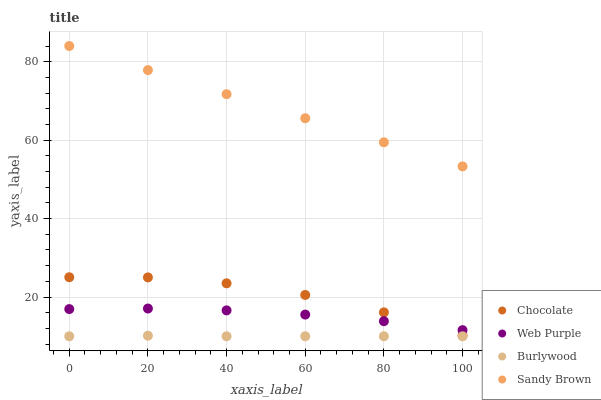Does Burlywood have the minimum area under the curve?
Answer yes or no. Yes. Does Sandy Brown have the maximum area under the curve?
Answer yes or no. Yes. Does Web Purple have the minimum area under the curve?
Answer yes or no. No. Does Web Purple have the maximum area under the curve?
Answer yes or no. No. Is Sandy Brown the smoothest?
Answer yes or no. Yes. Is Chocolate the roughest?
Answer yes or no. Yes. Is Web Purple the smoothest?
Answer yes or no. No. Is Web Purple the roughest?
Answer yes or no. No. Does Burlywood have the lowest value?
Answer yes or no. Yes. Does Web Purple have the lowest value?
Answer yes or no. No. Does Sandy Brown have the highest value?
Answer yes or no. Yes. Does Web Purple have the highest value?
Answer yes or no. No. Is Burlywood less than Web Purple?
Answer yes or no. Yes. Is Web Purple greater than Burlywood?
Answer yes or no. Yes. Does Chocolate intersect Web Purple?
Answer yes or no. Yes. Is Chocolate less than Web Purple?
Answer yes or no. No. Is Chocolate greater than Web Purple?
Answer yes or no. No. Does Burlywood intersect Web Purple?
Answer yes or no. No. 